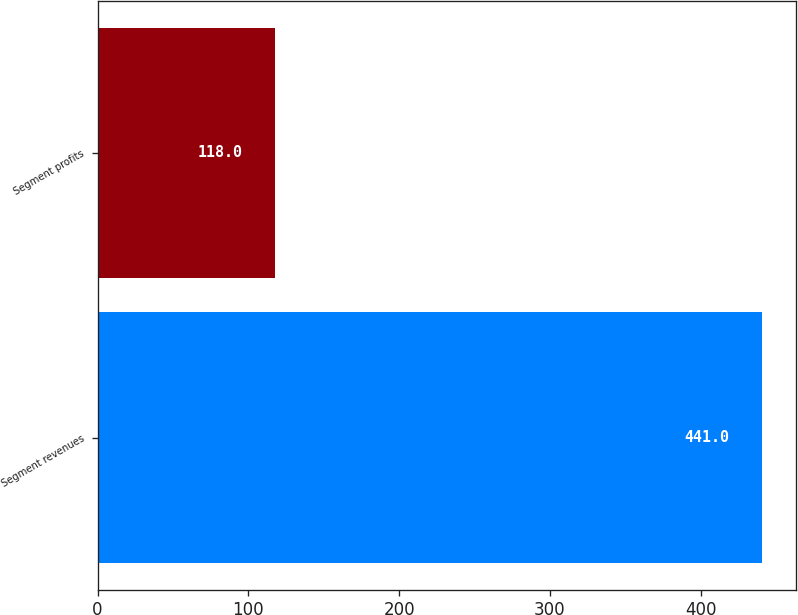<chart> <loc_0><loc_0><loc_500><loc_500><bar_chart><fcel>Segment revenues<fcel>Segment profits<nl><fcel>441<fcel>118<nl></chart> 